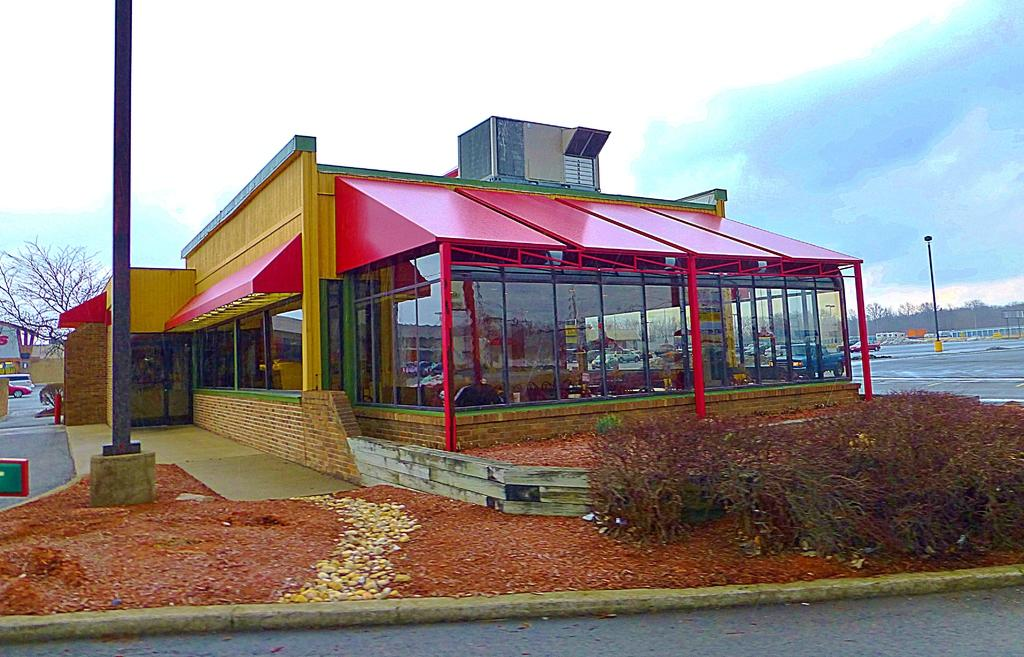What can be seen in the foreground of the picture? In the foreground of the picture, there are shrubs, stones, soil, a pole, and a building. Can you describe the ground in the foreground of the picture? The ground in the foreground of the picture consists of shrubs, stones, and soil. What is present in the background of the picture? In the background of the picture, there are trees, vehicles, another pole, and buildings. How is the sky depicted in the image? The sky is depicted as cloudy in the image. Who is the manager of the stream in the image? There is no stream present in the image, so there is no manager to be identified. What angle is the building in the image leaning at? The buildings in the image are not depicted as leaning, so there is no angle to be determined. 